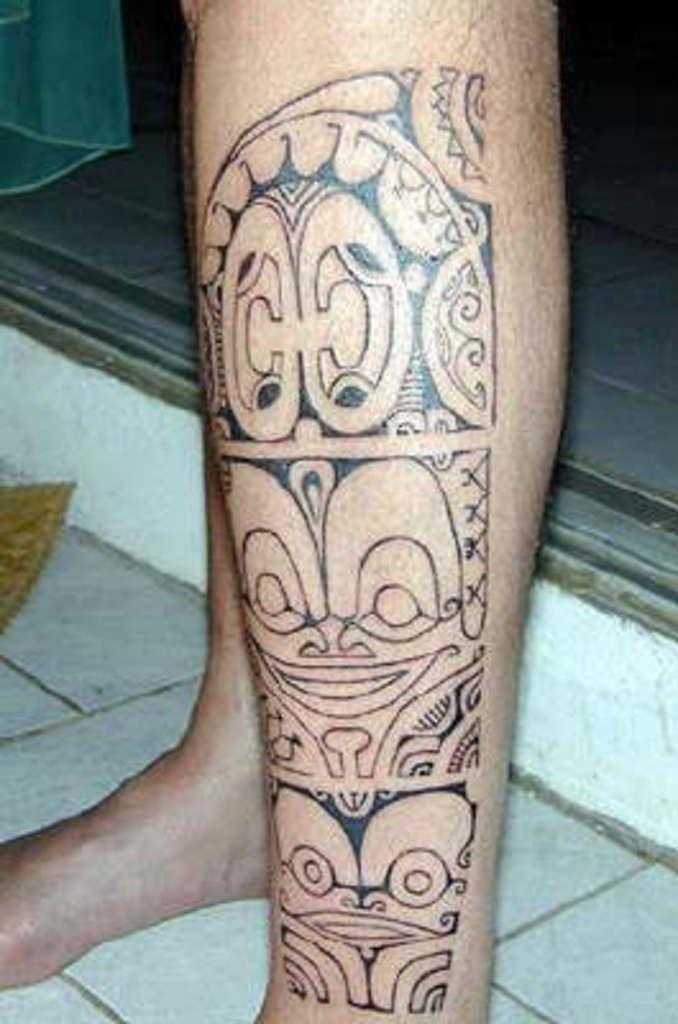What body part is visible in the image? There are person's legs in the image. What can be seen in front of the sill? There is art visible in front of the sill. What type of bone can be seen in the image? There is no bone visible in the image; it features person's legs and art in front of the sill. 